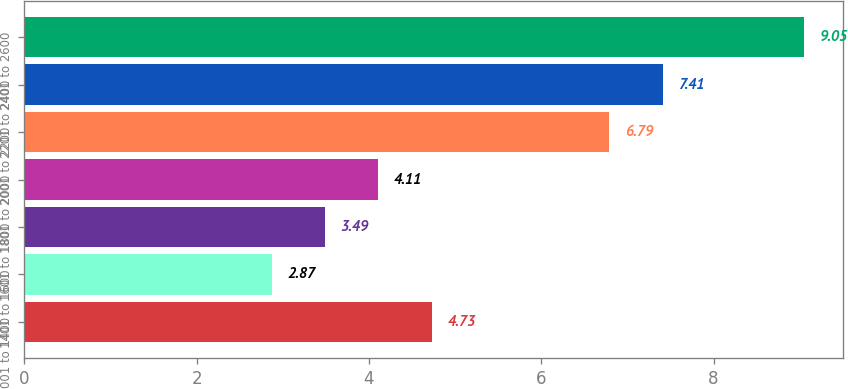Convert chart. <chart><loc_0><loc_0><loc_500><loc_500><bar_chart><fcel>001 to 1400<fcel>1401 to 1600<fcel>1601 to 1800<fcel>1801 to 2000<fcel>2001 to 2200<fcel>2201 to 2400<fcel>2401 to 2600<nl><fcel>4.73<fcel>2.87<fcel>3.49<fcel>4.11<fcel>6.79<fcel>7.41<fcel>9.05<nl></chart> 